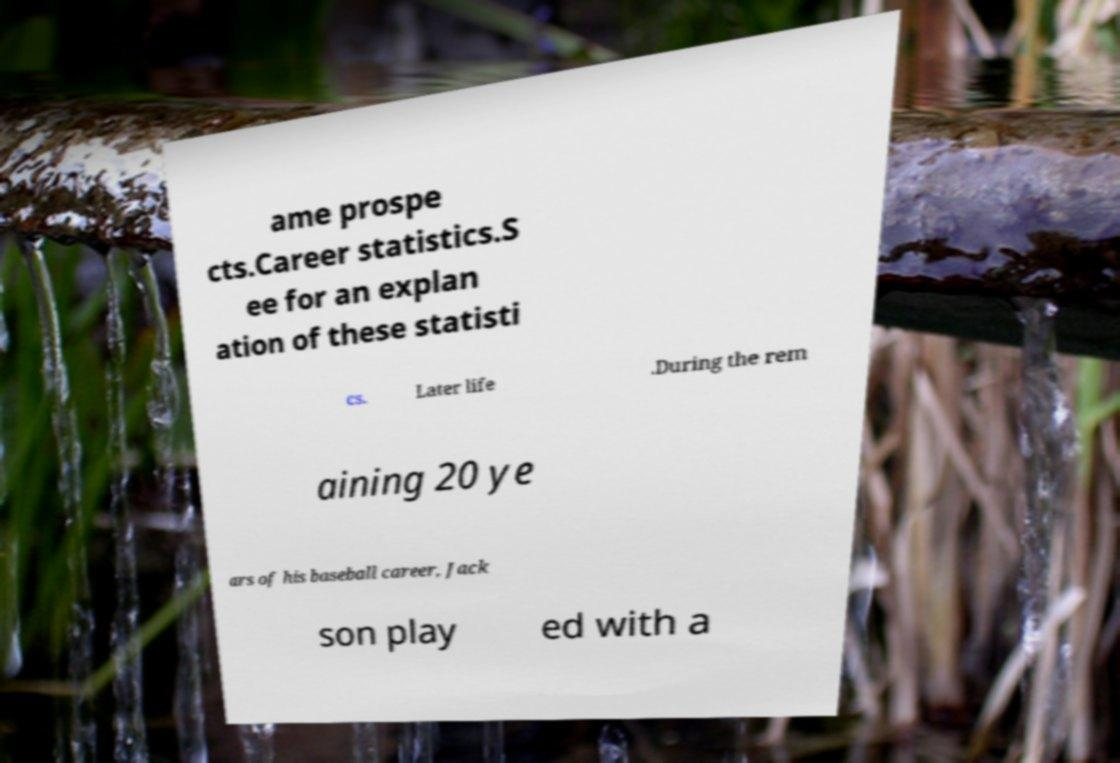There's text embedded in this image that I need extracted. Can you transcribe it verbatim? ame prospe cts.Career statistics.S ee for an explan ation of these statisti cs. Later life .During the rem aining 20 ye ars of his baseball career, Jack son play ed with a 